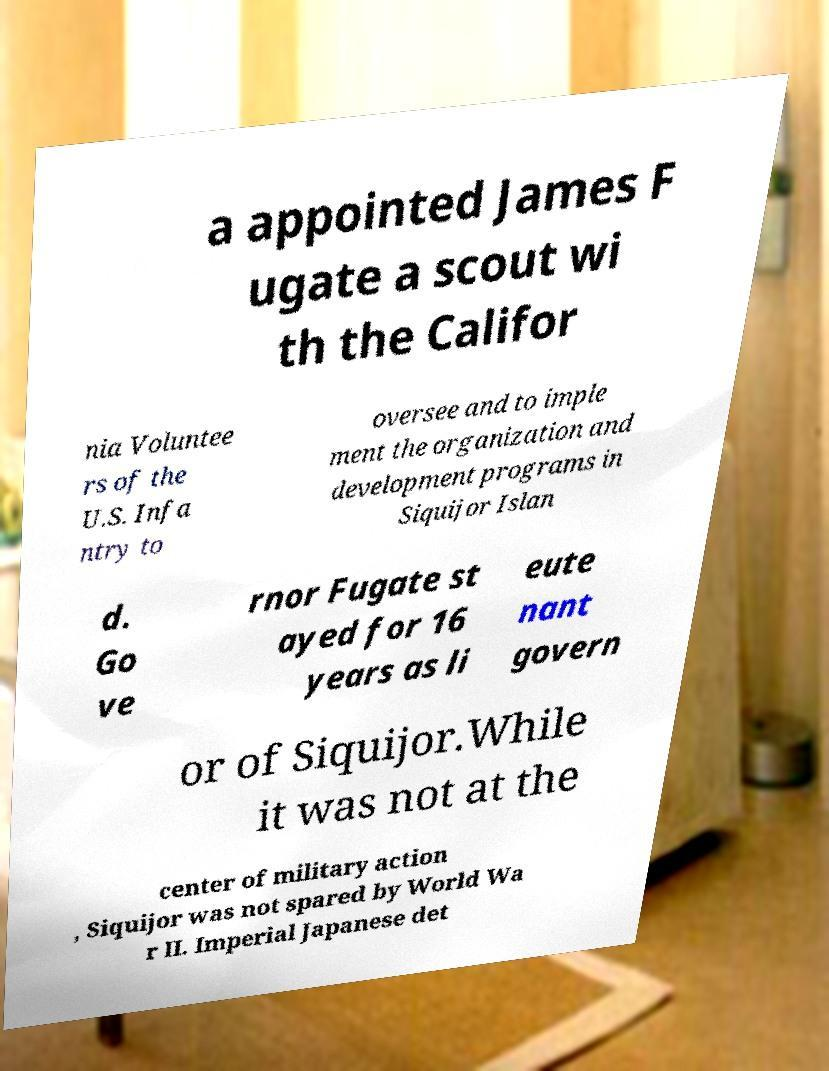Please identify and transcribe the text found in this image. a appointed James F ugate a scout wi th the Califor nia Voluntee rs of the U.S. Infa ntry to oversee and to imple ment the organization and development programs in Siquijor Islan d. Go ve rnor Fugate st ayed for 16 years as li eute nant govern or of Siquijor.While it was not at the center of military action , Siquijor was not spared by World Wa r II. Imperial Japanese det 